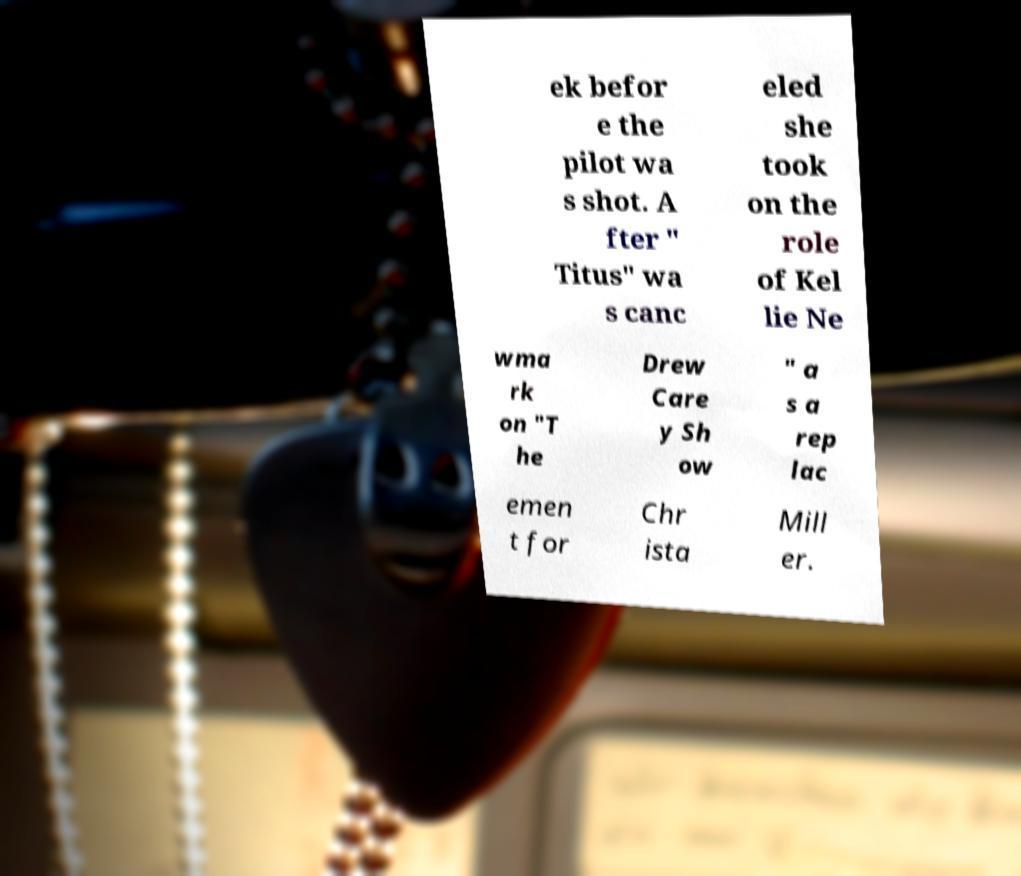There's text embedded in this image that I need extracted. Can you transcribe it verbatim? ek befor e the pilot wa s shot. A fter " Titus" wa s canc eled she took on the role of Kel lie Ne wma rk on "T he Drew Care y Sh ow " a s a rep lac emen t for Chr ista Mill er. 